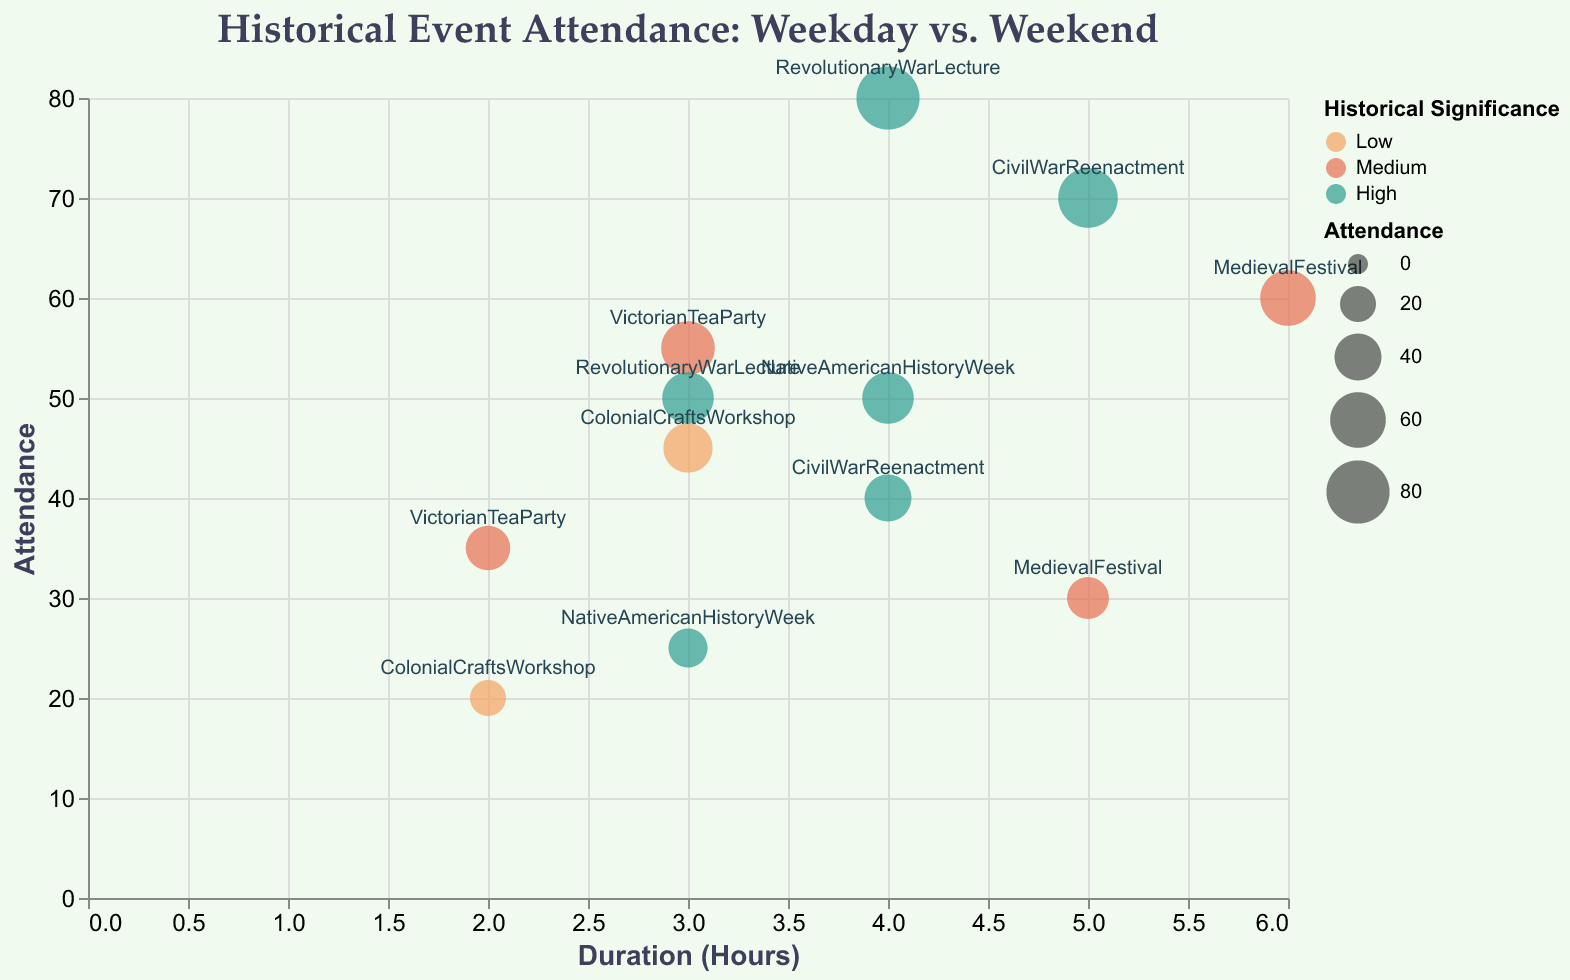What is the event with the highest attendance? By looking at the y-axis (Attendance), the event with the highest bubble on the chart is the Revolutionary War Lecture on Saturday.
Answer: Revolutionary War Lecture (Saturday) Which events occur on weekends and have a medium historical significance? By looking at the colors representing historical significance and the tooltips for the days of the week, the Victorian Tea Party on Saturday and the Medieval Festival on Friday have medium historical significance and occur on weekends.
Answer: VictorianTeaParty (Saturday), MedievalFestival (Friday) What is the average attendance for events with high historical significance? Identify the attendance values for high historical significance (Civil War Reenactment on Wednesday and Friday, Revolutionary War Lecture on Thursday and Saturday, Native American History Week on Wednesday and Sunday): (40 + 70 + 50 + 80 + 25 + 50) = 315, then divide by the number of events, which is 6. The average is 315/6.
Answer: 52.5 Which event has the longest duration and what is its attendance? By looking at the x-axis (Duration Hours), the Medieval Festival on Friday has the longest duration of 6 hours and its attendance is 60, as shown in the tooltip.
Answer: Medieval Festival (Friday), 60 How does attendance differ between weekday and weekend for the Colonial Crafts Workshop? By looking at the y-axis for each instance of the Colonial Crafts Workshop, on Tuesday (weekday) the attendance is 20, and on Sunday (weekend) the attendance is 45. The attendance on the weekend is higher.
Answer: Weekday: 20, Weekend: 45 Which event has the smallest size bubble and what does this signify about its attendance? By looking at the size of the bubbles, the smallest bubble corresponds to the Colonial Crafts Workshop on Tuesday, and this signifies its attendance is the lowest at 20.
Answer: Colonial Crafts Workshop (Tuesday), 20 What is the range of attendance for events occurring in Greenfield Park? Identify attendance values for events in Greenfield Park (Civil War Reenactment on Wednesday and Friday): 40 and 70. The range is calculated as 70 - 40.
Answer: 30 Compare the attendance between events having the same historical significance but different durations. For instance, compare the Civil War Reenactment on Friday (70) with 5 hours duration to the Revolutionary War Lecture on Thursday (50) with 3 hours duration. The attendance is higher for the Civil War Reenactment on Friday despite longer duration.
Answer: Civil War Reenactment (Friday): 70, Revolutionary War Lecture (Thursday): 50 Do events with longer duration consistently have higher attendance? By examining the x-axis (Duration Hours) and y-axis (Attendance), there is no consistent pattern indicating that longer-duration events have higher attendance as there are exceptions like the Colonial Crafts Workshop on Sunday (3 hours, 45 attendance) vs. Revolutionary War Lecture on Thursday (3 hours, 50 attendance).
Answer: No 